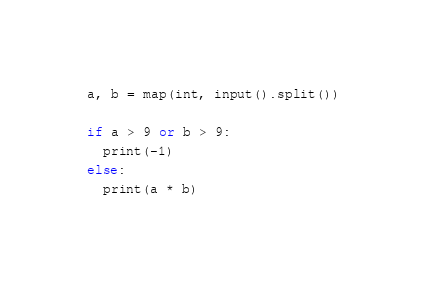Convert code to text. <code><loc_0><loc_0><loc_500><loc_500><_Python_>a, b = map(int, input().split())

if a > 9 or b > 9:
  print(-1)
else:
  print(a * b)</code> 